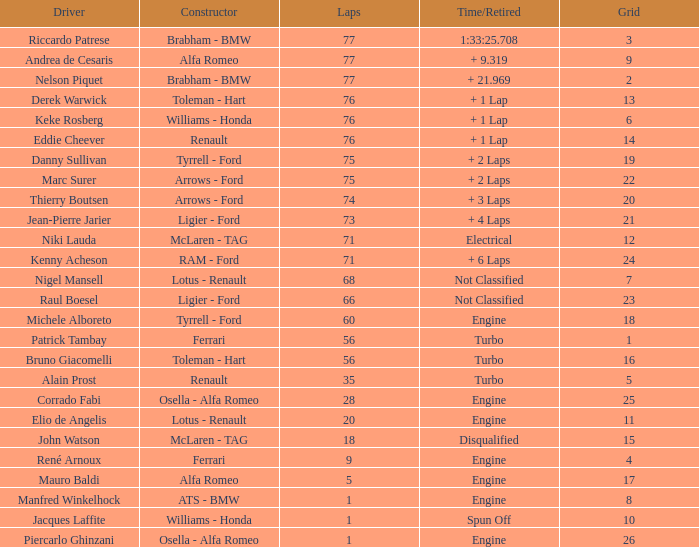Who drove the grid 10 car? Jacques Laffite. 